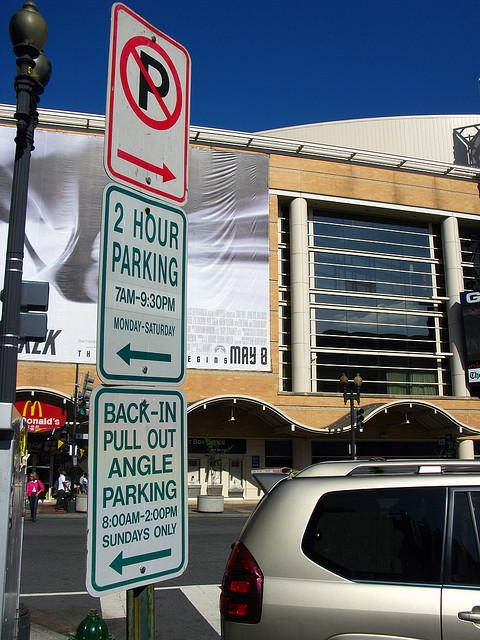The billboard on the building is advertising for which science fiction franchise?

Choices:
A) stargate
B) dune
C) star wars
D) star trek star trek 